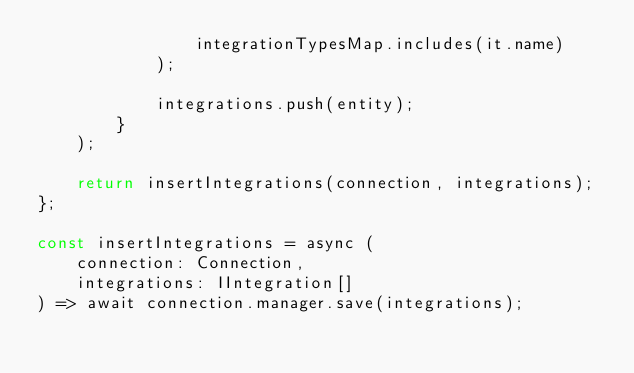Convert code to text. <code><loc_0><loc_0><loc_500><loc_500><_TypeScript_>				integrationTypesMap.includes(it.name)
			);

			integrations.push(entity);
		}
	);

	return insertIntegrations(connection, integrations);
};

const insertIntegrations = async (
	connection: Connection,
	integrations: IIntegration[]
) => await connection.manager.save(integrations);
</code> 